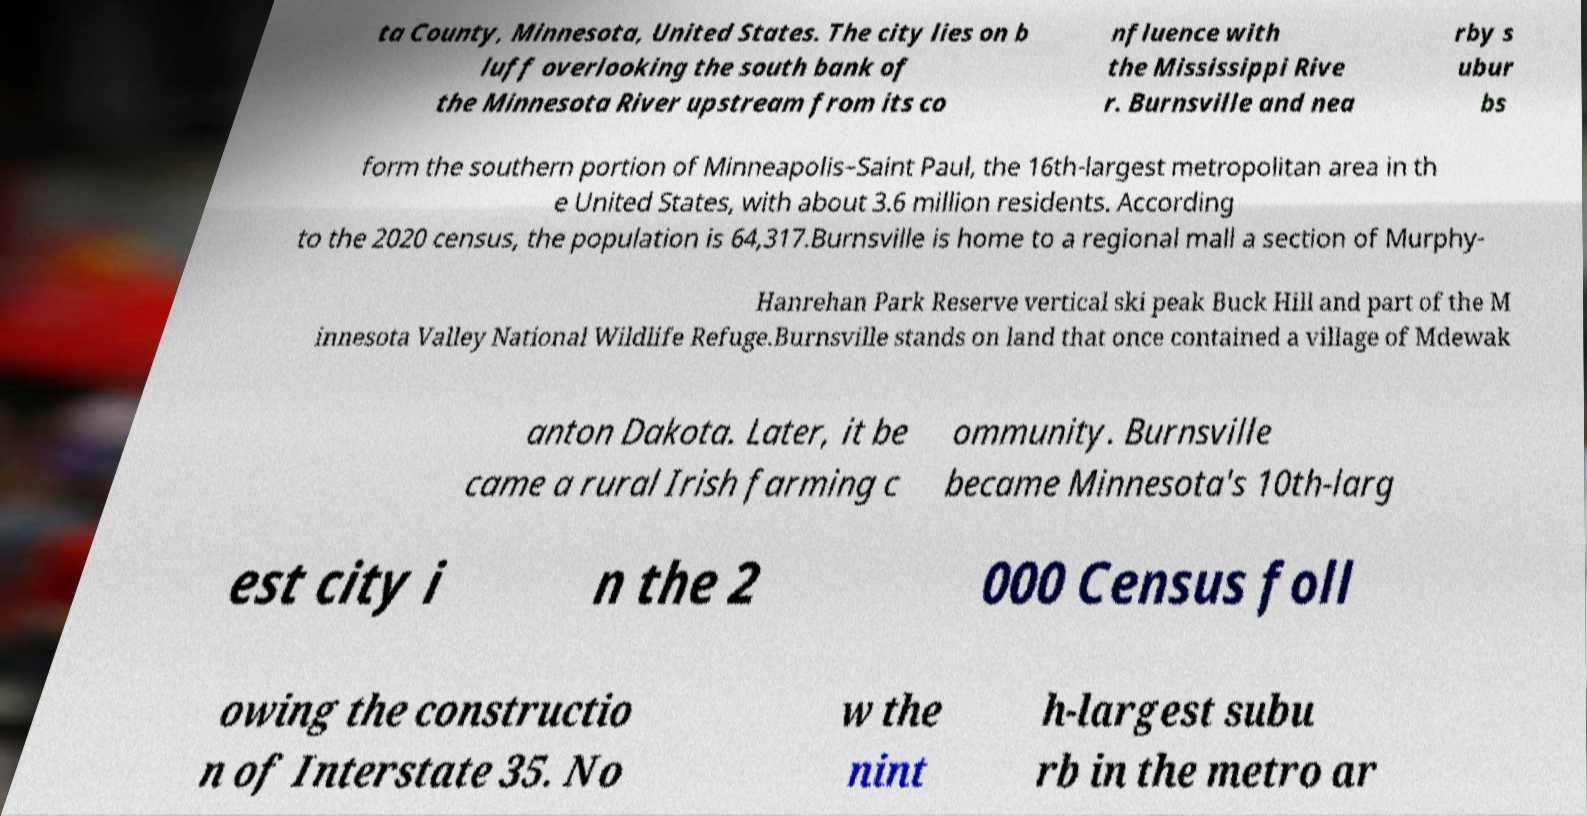Please read and relay the text visible in this image. What does it say? ta County, Minnesota, United States. The city lies on b luff overlooking the south bank of the Minnesota River upstream from its co nfluence with the Mississippi Rive r. Burnsville and nea rby s ubur bs form the southern portion of Minneapolis–Saint Paul, the 16th-largest metropolitan area in th e United States, with about 3.6 million residents. According to the 2020 census, the population is 64,317.Burnsville is home to a regional mall a section of Murphy- Hanrehan Park Reserve vertical ski peak Buck Hill and part of the M innesota Valley National Wildlife Refuge.Burnsville stands on land that once contained a village of Mdewak anton Dakota. Later, it be came a rural Irish farming c ommunity. Burnsville became Minnesota's 10th-larg est city i n the 2 000 Census foll owing the constructio n of Interstate 35. No w the nint h-largest subu rb in the metro ar 